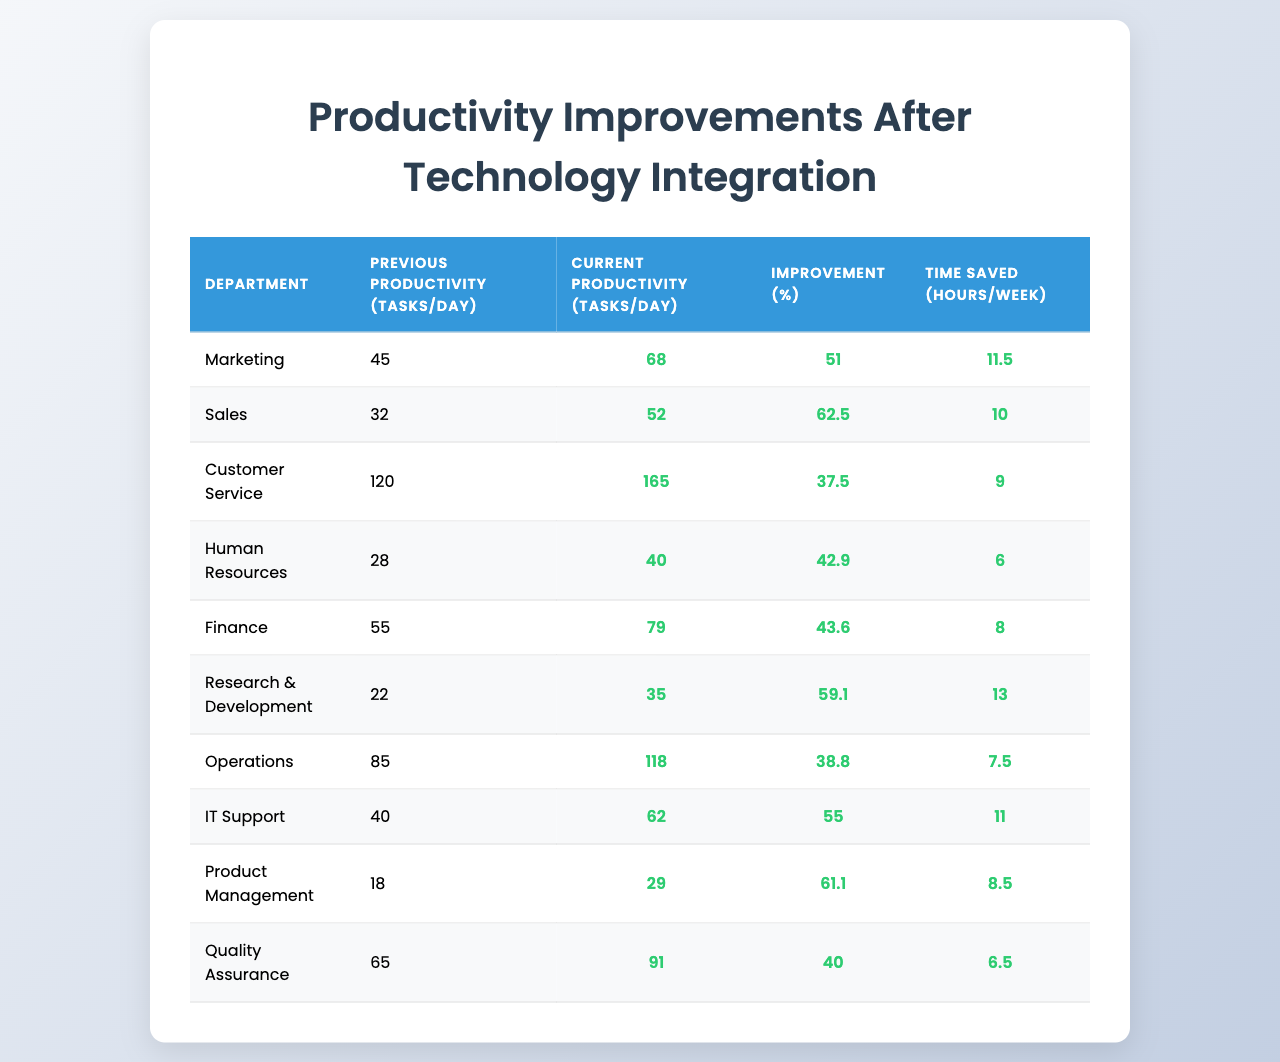What is the previous productivity for the Sales department? Referring to the table, under the "Previous Productivity (tasks/day)" column for the Sales department, the value listed is 32.
Answer: 32 What was the improvement percentage for Customer Service? Looking at the "Improvement (%)" column corresponding to Customer Service, the value is 37.5%.
Answer: 37.5% Which department achieved the highest improvement percentage? By comparing all the values in the "Improvement (%)" column, Research & Development recorded the highest improvement of 59.1%.
Answer: Research & Development How many tasks per day does the IT Support department currently handle? In the "Current Productivity (tasks/day)" column for IT Support, the figure is 62 tasks.
Answer: 62 What is the average improvement percentage across all departments? To calculate this, sum all the improvement percentages (51 + 62.5 + 37.5 + 42.9 + 43.6 + 59.1 + 38.8 + 55 + 61.1 + 40) =  426.5. There are 10 departments, so the average is 426.5 / 10 = 42.65%.
Answer: 42.65% Did the Operations department save more hours per week than the Human Resources department? Operations saved 7.5 hours/week while Human Resources saved 6 hours/week, and since 7.5 is greater than 6, the answer is yes.
Answer: Yes If we consider the top three departments by time saved, which department comes in third? Sorting the "Time Saved (hours/week)" column: Marketing (11.5), IT Support (11), and then Sales (10). Thus, the third department is Sales.
Answer: Sales Is there any department that has an improvement percentage lower than 40%? Upon reviewing the "Improvement (%)" column, Human Resources (42.9%) and Quality Assurance (40%) are both above 40%, while Customer Service (37.5%) is below, fulfilling the condition.
Answer: Yes What is the total number of tasks per day handled by all departments before integrating the new technology? Summing the "Previous Productivity (tasks/day)" values: 45 + 32 + 120 + 28 + 55 + 22 + 85 + 40 + 18 + 65 = 440 tasks per day in total.
Answer: 440 How much total time is saved per week across all departments after the technology integration? We add the values in "Time Saved (hours/week)" column: 11.5 + 10 + 9 + 6 + 8 + 13 + 7.5 + 11 + 8.5 + 6.5 =  83 hours/week saved in total.
Answer: 83 